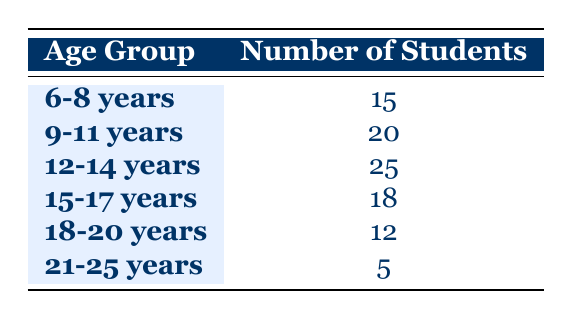What is the age group with the highest number of students participating in ensembles? Looking at the table, we can see that the age group "12-14 years" has the largest number of students, which is 25.
Answer: 12-14 years How many students are in the age group of 9-11 years? The table directly shows that there are 20 students in the age group of 9-11 years.
Answer: 20 What is the total number of students participating in ensembles across all age groups? We sum the number of students in each age group: 15 + 20 + 25 + 18 + 12 + 5 = 95.
Answer: 95 Is there an age group with at least 20 students? Yes, both the age groups "9-11 years" and "12-14 years" have 20 and 25 students respectively, which is at least 20.
Answer: Yes What is the difference in the number of students between the age groups 15-17 years and 18-20 years? For the age group "15-17 years," there are 18 students, and for "18-20 years," there are 12 students. The difference is 18 - 12 = 6.
Answer: 6 What percentage of the students are in the age group 21-25 years? The number of students in the age group "21-25 years" is 5. To find the percentage, we calculate (5 / 95) * 100, which gives us approximately 5.26%.
Answer: 5.26% Which age group has the least number of students, and how many? By examining the table, we see that the age group "21-25 years" has the smallest number of students, which is 5.
Answer: 21-25 years, 5 If we combine the age groups 6-8 years and 9-11 years, how many students are there in total? We add the number of students from both age groups: 15 (from 6-8 years) + 20 (from 9-11 years) = 35.
Answer: 35 Are there more students in the age group 15-17 years than in the age group 21-25 years? Yes, the age group "15-17 years" has 18 students while "21-25 years" has only 5 students, so there are more students in the former.
Answer: Yes 